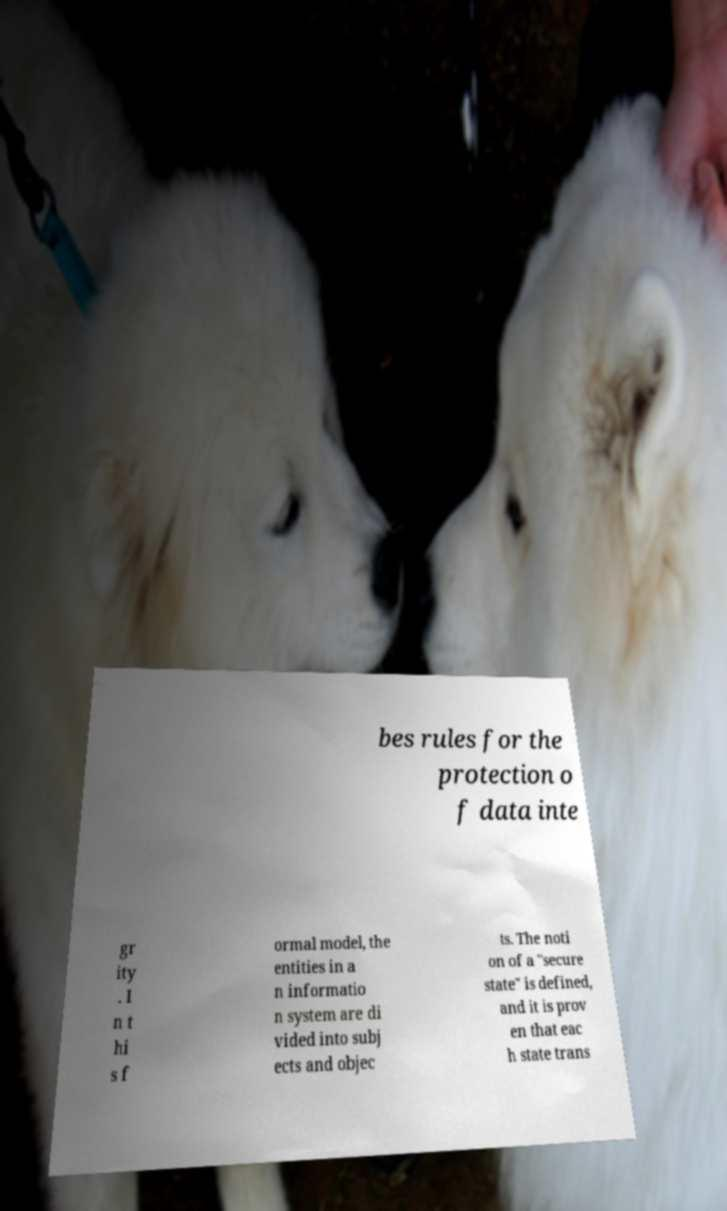Please identify and transcribe the text found in this image. bes rules for the protection o f data inte gr ity . I n t hi s f ormal model, the entities in a n informatio n system are di vided into subj ects and objec ts. The noti on of a "secure state" is defined, and it is prov en that eac h state trans 